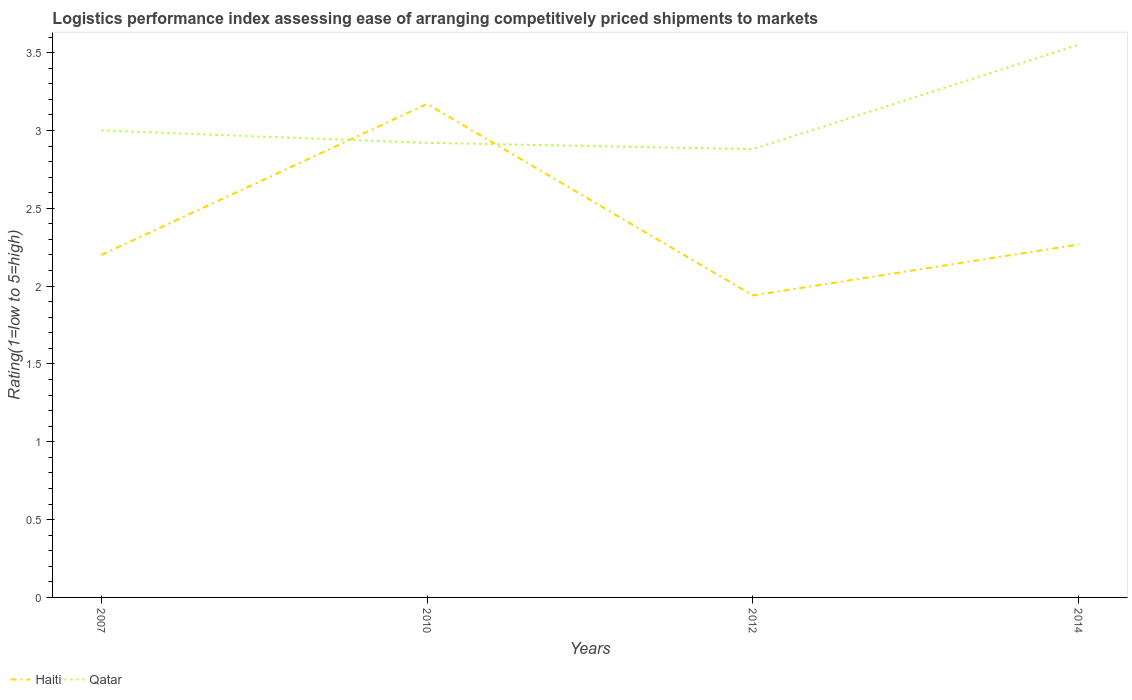How many different coloured lines are there?
Give a very brief answer. 2. Across all years, what is the maximum Logistic performance index in Qatar?
Your response must be concise. 2.88. In which year was the Logistic performance index in Qatar maximum?
Offer a very short reply. 2012. What is the total Logistic performance index in Qatar in the graph?
Keep it short and to the point. -0.55. What is the difference between the highest and the second highest Logistic performance index in Qatar?
Provide a short and direct response. 0.67. What is the difference between the highest and the lowest Logistic performance index in Qatar?
Keep it short and to the point. 1. How many lines are there?
Your answer should be very brief. 2. What is the difference between two consecutive major ticks on the Y-axis?
Make the answer very short. 0.5. Are the values on the major ticks of Y-axis written in scientific E-notation?
Your answer should be very brief. No. Does the graph contain any zero values?
Offer a very short reply. No. Where does the legend appear in the graph?
Ensure brevity in your answer.  Bottom left. What is the title of the graph?
Provide a short and direct response. Logistics performance index assessing ease of arranging competitively priced shipments to markets. What is the label or title of the X-axis?
Provide a succinct answer. Years. What is the label or title of the Y-axis?
Your answer should be very brief. Rating(1=low to 5=high). What is the Rating(1=low to 5=high) in Qatar in 2007?
Keep it short and to the point. 3. What is the Rating(1=low to 5=high) of Haiti in 2010?
Your answer should be very brief. 3.17. What is the Rating(1=low to 5=high) of Qatar in 2010?
Make the answer very short. 2.92. What is the Rating(1=low to 5=high) in Haiti in 2012?
Offer a very short reply. 1.94. What is the Rating(1=low to 5=high) of Qatar in 2012?
Offer a very short reply. 2.88. What is the Rating(1=low to 5=high) in Haiti in 2014?
Offer a very short reply. 2.27. What is the Rating(1=low to 5=high) of Qatar in 2014?
Provide a short and direct response. 3.55. Across all years, what is the maximum Rating(1=low to 5=high) of Haiti?
Give a very brief answer. 3.17. Across all years, what is the maximum Rating(1=low to 5=high) in Qatar?
Your response must be concise. 3.55. Across all years, what is the minimum Rating(1=low to 5=high) in Haiti?
Keep it short and to the point. 1.94. Across all years, what is the minimum Rating(1=low to 5=high) of Qatar?
Your response must be concise. 2.88. What is the total Rating(1=low to 5=high) in Haiti in the graph?
Provide a succinct answer. 9.58. What is the total Rating(1=low to 5=high) in Qatar in the graph?
Your answer should be compact. 12.35. What is the difference between the Rating(1=low to 5=high) of Haiti in 2007 and that in 2010?
Offer a terse response. -0.97. What is the difference between the Rating(1=low to 5=high) in Haiti in 2007 and that in 2012?
Make the answer very short. 0.26. What is the difference between the Rating(1=low to 5=high) in Qatar in 2007 and that in 2012?
Keep it short and to the point. 0.12. What is the difference between the Rating(1=low to 5=high) in Haiti in 2007 and that in 2014?
Offer a terse response. -0.07. What is the difference between the Rating(1=low to 5=high) of Qatar in 2007 and that in 2014?
Give a very brief answer. -0.55. What is the difference between the Rating(1=low to 5=high) of Haiti in 2010 and that in 2012?
Your answer should be very brief. 1.23. What is the difference between the Rating(1=low to 5=high) in Haiti in 2010 and that in 2014?
Give a very brief answer. 0.9. What is the difference between the Rating(1=low to 5=high) of Qatar in 2010 and that in 2014?
Your response must be concise. -0.63. What is the difference between the Rating(1=low to 5=high) in Haiti in 2012 and that in 2014?
Make the answer very short. -0.33. What is the difference between the Rating(1=low to 5=high) in Qatar in 2012 and that in 2014?
Your answer should be very brief. -0.67. What is the difference between the Rating(1=low to 5=high) of Haiti in 2007 and the Rating(1=low to 5=high) of Qatar in 2010?
Your response must be concise. -0.72. What is the difference between the Rating(1=low to 5=high) in Haiti in 2007 and the Rating(1=low to 5=high) in Qatar in 2012?
Your answer should be very brief. -0.68. What is the difference between the Rating(1=low to 5=high) in Haiti in 2007 and the Rating(1=low to 5=high) in Qatar in 2014?
Offer a very short reply. -1.35. What is the difference between the Rating(1=low to 5=high) of Haiti in 2010 and the Rating(1=low to 5=high) of Qatar in 2012?
Provide a short and direct response. 0.29. What is the difference between the Rating(1=low to 5=high) in Haiti in 2010 and the Rating(1=low to 5=high) in Qatar in 2014?
Offer a terse response. -0.38. What is the difference between the Rating(1=low to 5=high) of Haiti in 2012 and the Rating(1=low to 5=high) of Qatar in 2014?
Provide a succinct answer. -1.61. What is the average Rating(1=low to 5=high) of Haiti per year?
Provide a succinct answer. 2.39. What is the average Rating(1=low to 5=high) of Qatar per year?
Your answer should be very brief. 3.09. In the year 2007, what is the difference between the Rating(1=low to 5=high) in Haiti and Rating(1=low to 5=high) in Qatar?
Provide a succinct answer. -0.8. In the year 2012, what is the difference between the Rating(1=low to 5=high) in Haiti and Rating(1=low to 5=high) in Qatar?
Give a very brief answer. -0.94. In the year 2014, what is the difference between the Rating(1=low to 5=high) in Haiti and Rating(1=low to 5=high) in Qatar?
Ensure brevity in your answer.  -1.28. What is the ratio of the Rating(1=low to 5=high) in Haiti in 2007 to that in 2010?
Make the answer very short. 0.69. What is the ratio of the Rating(1=low to 5=high) in Qatar in 2007 to that in 2010?
Your answer should be very brief. 1.03. What is the ratio of the Rating(1=low to 5=high) of Haiti in 2007 to that in 2012?
Your answer should be very brief. 1.13. What is the ratio of the Rating(1=low to 5=high) of Qatar in 2007 to that in 2012?
Give a very brief answer. 1.04. What is the ratio of the Rating(1=low to 5=high) in Haiti in 2007 to that in 2014?
Keep it short and to the point. 0.97. What is the ratio of the Rating(1=low to 5=high) of Qatar in 2007 to that in 2014?
Provide a succinct answer. 0.84. What is the ratio of the Rating(1=low to 5=high) of Haiti in 2010 to that in 2012?
Provide a short and direct response. 1.63. What is the ratio of the Rating(1=low to 5=high) of Qatar in 2010 to that in 2012?
Your answer should be very brief. 1.01. What is the ratio of the Rating(1=low to 5=high) in Haiti in 2010 to that in 2014?
Your response must be concise. 1.4. What is the ratio of the Rating(1=low to 5=high) of Qatar in 2010 to that in 2014?
Offer a terse response. 0.82. What is the ratio of the Rating(1=low to 5=high) in Haiti in 2012 to that in 2014?
Provide a succinct answer. 0.86. What is the ratio of the Rating(1=low to 5=high) of Qatar in 2012 to that in 2014?
Your answer should be very brief. 0.81. What is the difference between the highest and the second highest Rating(1=low to 5=high) of Haiti?
Give a very brief answer. 0.9. What is the difference between the highest and the second highest Rating(1=low to 5=high) in Qatar?
Your answer should be compact. 0.55. What is the difference between the highest and the lowest Rating(1=low to 5=high) of Haiti?
Ensure brevity in your answer.  1.23. What is the difference between the highest and the lowest Rating(1=low to 5=high) in Qatar?
Your answer should be very brief. 0.67. 